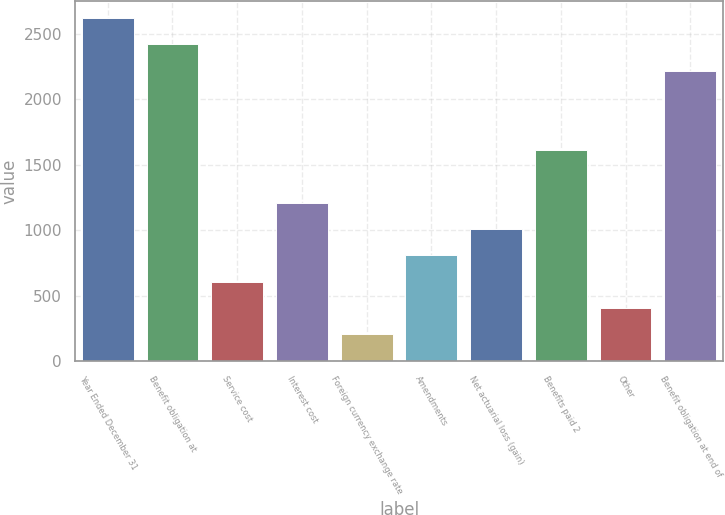Convert chart. <chart><loc_0><loc_0><loc_500><loc_500><bar_chart><fcel>Year Ended December 31<fcel>Benefit obligation at<fcel>Service cost<fcel>Interest cost<fcel>Foreign currency exchange rate<fcel>Amendments<fcel>Net actuarial loss (gain)<fcel>Benefits paid 2<fcel>Other<fcel>Benefit obligation at end of<nl><fcel>2621.2<fcel>2419.8<fcel>607.2<fcel>1211.4<fcel>204.4<fcel>808.6<fcel>1010<fcel>1614.2<fcel>405.8<fcel>2218.4<nl></chart> 